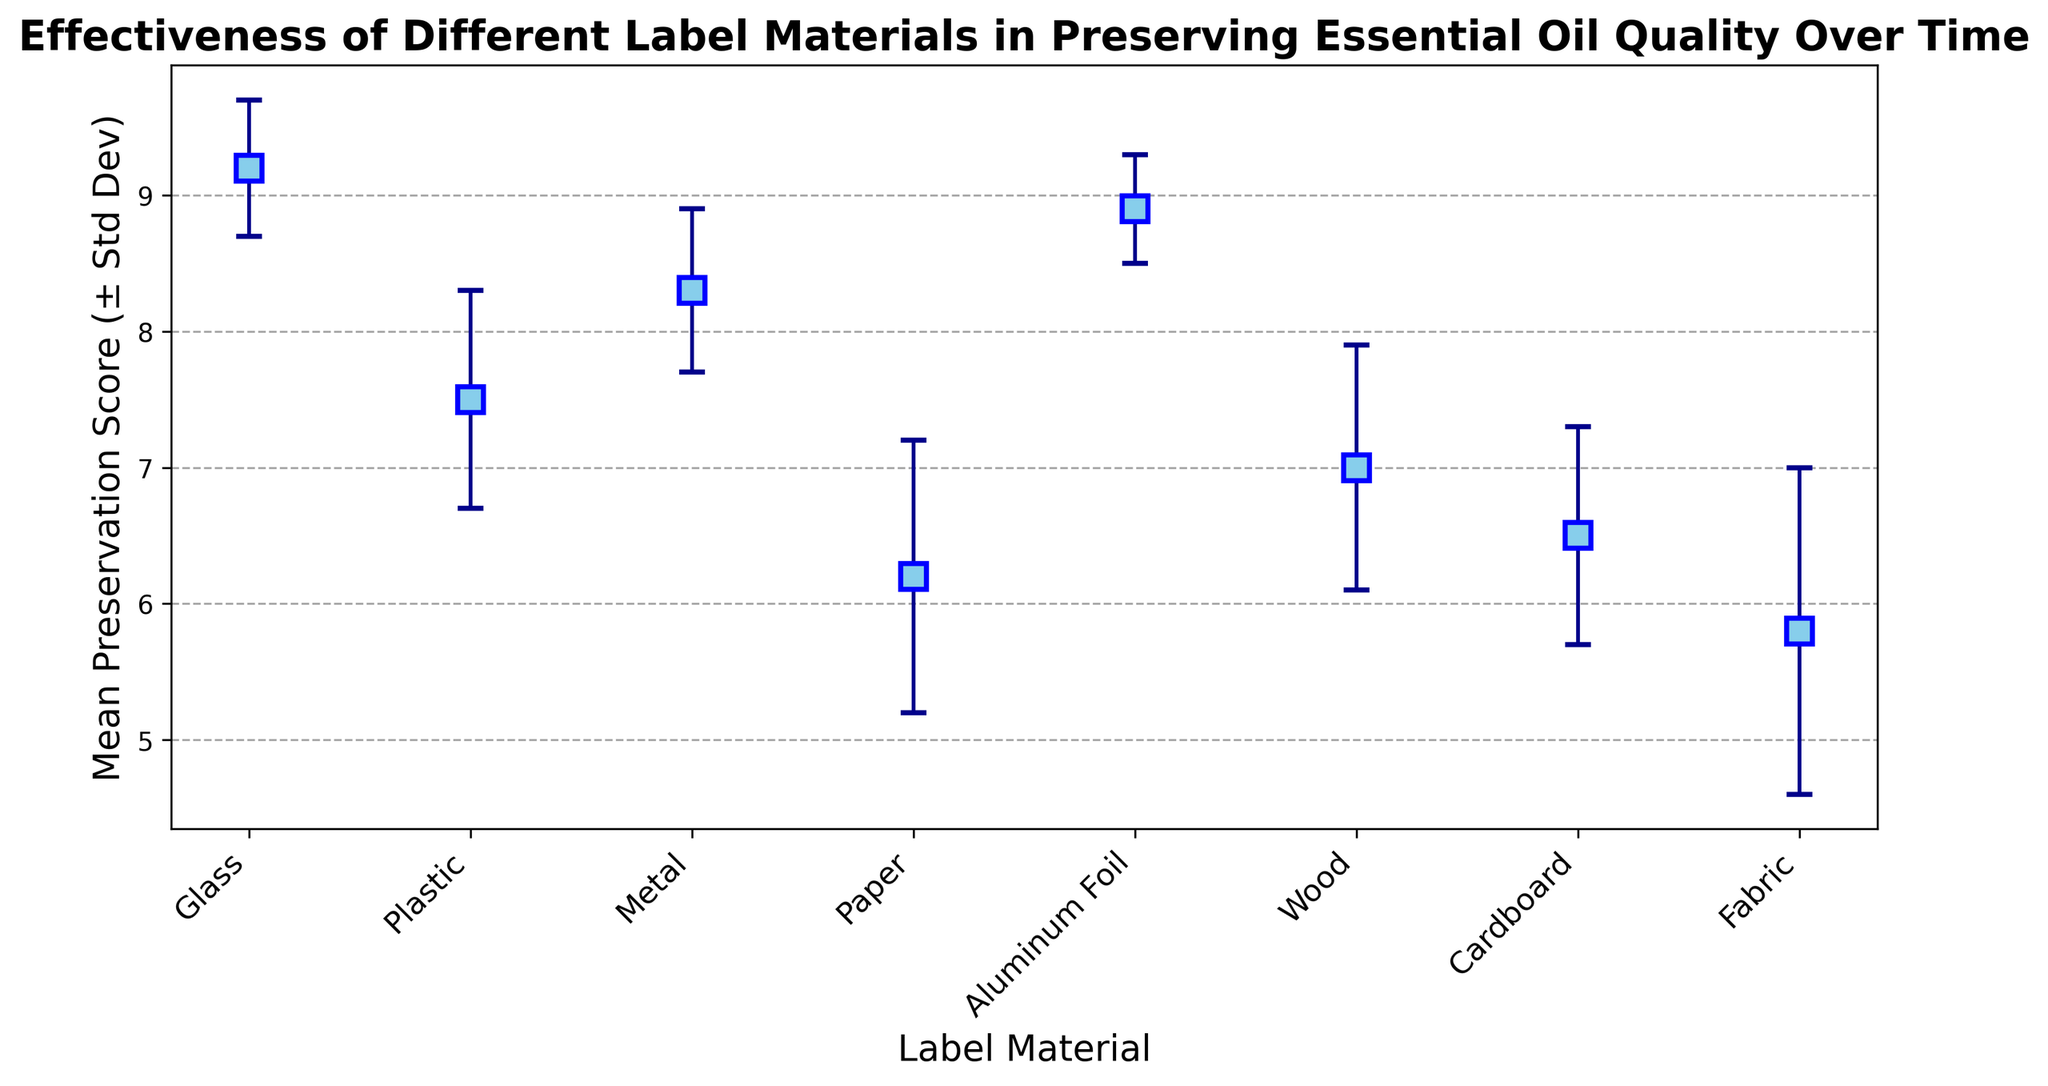What's the mean preservation score for Glass? Locate the point for "Glass" on the x-axis, then look up its corresponding mean preservation score value on the y-axis.
Answer: 9.2 Which material has the highest mean preservation score? Identify the point with the highest value on the y-axis and note the corresponding material on the x-axis.
Answer: Glass What is the difference between the mean preservation scores of Glass and Paper? Find the mean preservation scores for both "Glass" and "Paper". Subtract the score of Paper (6.2) from the score of Glass (9.2). Calculation: 9.2 - 6.2 = 3.0
Answer: 3.0 Which material has the largest standard deviation in preservation score? Look at the error bars representing the standard deviations and identify the material with the longest error bar.
Answer: Fabric Between Plastic and Aluminum Foil, which material preserves essential oil quality better on average? Compare the mean preservation scores for "Plastic" and "Aluminum Foil". Aluminum Foil has a higher mean score (8.9) than Plastic (7.5).
Answer: Aluminum Foil Which material has the smallest error bar? Identify the material with the shortest error bar.
Answer: Aluminum Foil How does Metal compare to Wood in terms of mean preservation score? Compare the mean preservation scores for "Metal" (8.3) and "Wood" (7.0). Metal has a higher mean score than Wood.
Answer: Metal What is the average mean preservation score of all materials shown? Sum the mean preservation scores of all materials and divide by the number of materials. Calculation: (9.2 + 7.5 + 8.3 + 6.2 + 8.9 + 7.0 + 6.5 + 5.8) / 8 = 59.4 / 8 = 7.425
Answer: 7.43 Which material has a mean preservation score less than 7 but greater than 6? Identify materials with scores falling between 6 and 7. These are "Paper" (6.2) and "Cardboard" (6.5).
Answer: Paper and Cardboard What's the range of mean preservation scores for the materials shown? Subtract the smallest mean preservation score (5.8 for Fabric) from the largest (9.2 for Glass). Calculation: 9.2 - 5.8 = 3.4
Answer: 3.4 